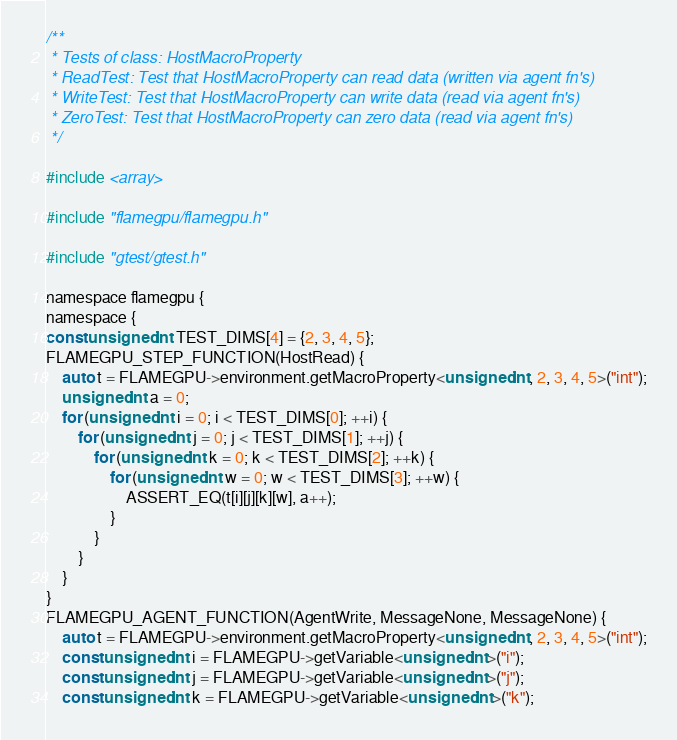<code> <loc_0><loc_0><loc_500><loc_500><_Cuda_>/**
 * Tests of class: HostMacroProperty
 * ReadTest: Test that HostMacroProperty can read data (written via agent fn's)
 * WriteTest: Test that HostMacroProperty can write data (read via agent fn's)
 * ZeroTest: Test that HostMacroProperty can zero data (read via agent fn's)
 */

#include <array>

#include "flamegpu/flamegpu.h"

#include "gtest/gtest.h"

namespace flamegpu {
namespace {
const unsigned int TEST_DIMS[4] = {2, 3, 4, 5};
FLAMEGPU_STEP_FUNCTION(HostRead) {
    auto t = FLAMEGPU->environment.getMacroProperty<unsigned int, 2, 3, 4, 5>("int");
    unsigned int a = 0;
    for (unsigned int i = 0; i < TEST_DIMS[0]; ++i) {
        for (unsigned int j = 0; j < TEST_DIMS[1]; ++j) {
            for (unsigned int k = 0; k < TEST_DIMS[2]; ++k) {
                for (unsigned int w = 0; w < TEST_DIMS[3]; ++w) {
                    ASSERT_EQ(t[i][j][k][w], a++);
                }
            }
        }
    }
}
FLAMEGPU_AGENT_FUNCTION(AgentWrite, MessageNone, MessageNone) {
    auto t = FLAMEGPU->environment.getMacroProperty<unsigned int, 2, 3, 4, 5>("int");
    const unsigned int i = FLAMEGPU->getVariable<unsigned int>("i");
    const unsigned int j = FLAMEGPU->getVariable<unsigned int>("j");
    const unsigned int k = FLAMEGPU->getVariable<unsigned int>("k");</code> 